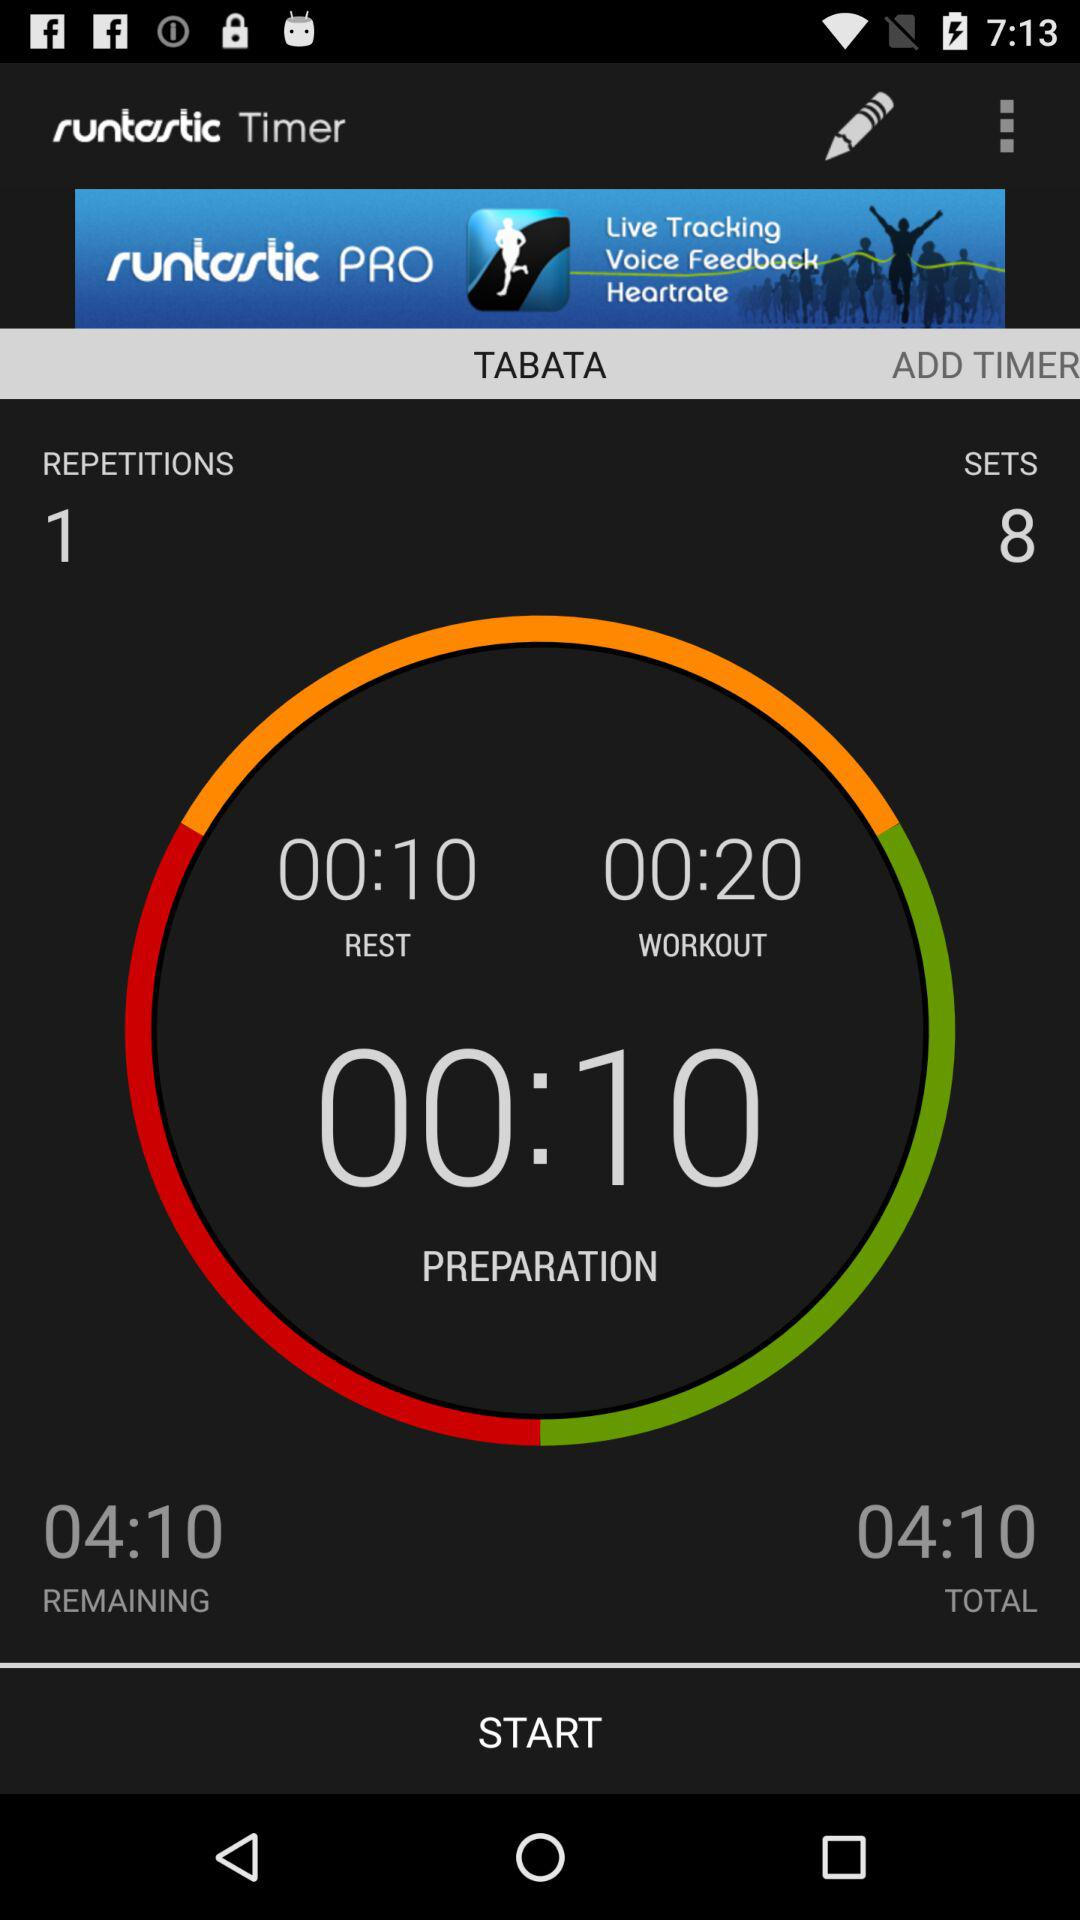What is the rest time? The rest time is 10 seconds. 